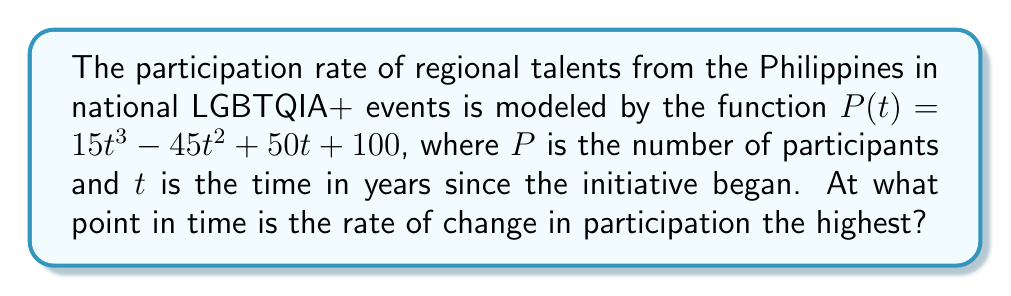Can you answer this question? To find the point in time when the rate of change in participation is highest, we need to follow these steps:

1) First, we need to find the derivative of $P(t)$ to get the rate of change function:
   $$P'(t) = 45t^2 - 90t + 50$$

2) The highest rate of change will occur at the maximum point of $P'(t)$. To find this, we need to find where the derivative of $P'(t)$ equals zero:
   $$P''(t) = 90t - 90$$

3) Set $P''(t) = 0$ and solve for $t$:
   $$90t - 90 = 0$$
   $$90t = 90$$
   $$t = 1$$

4) To confirm this is a maximum (not a minimum), we can check that $P'''(t) = 90 > 0$.

5) Therefore, the rate of change is highest when $t = 1$, which is one year after the initiative began.
Answer: 1 year 